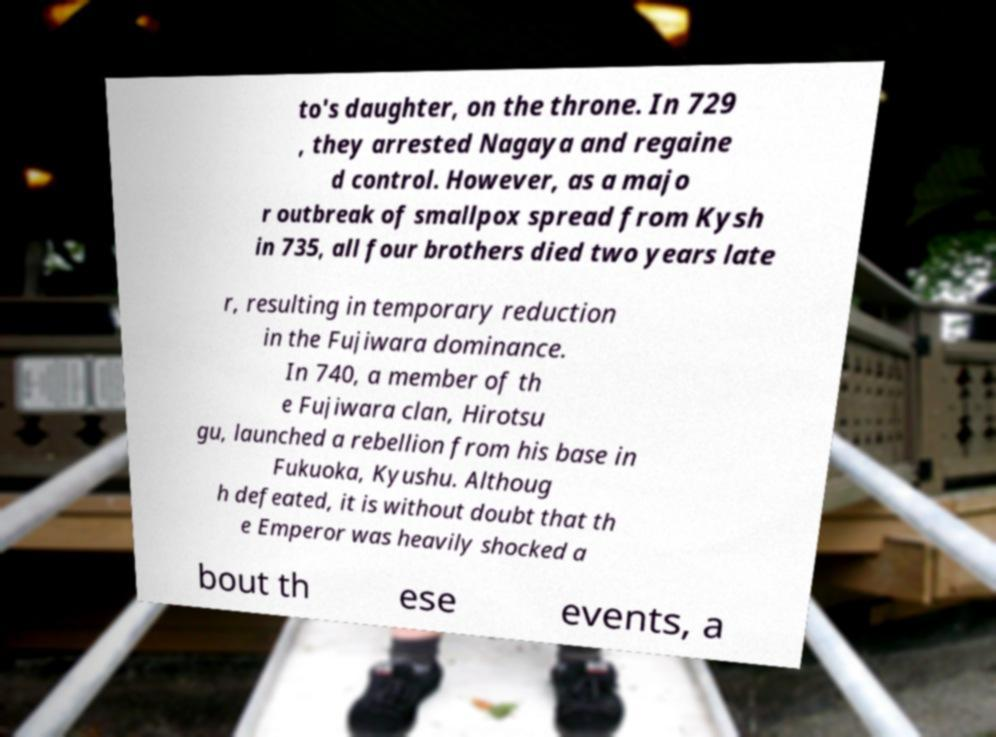Can you accurately transcribe the text from the provided image for me? to's daughter, on the throne. In 729 , they arrested Nagaya and regaine d control. However, as a majo r outbreak of smallpox spread from Kysh in 735, all four brothers died two years late r, resulting in temporary reduction in the Fujiwara dominance. In 740, a member of th e Fujiwara clan, Hirotsu gu, launched a rebellion from his base in Fukuoka, Kyushu. Althoug h defeated, it is without doubt that th e Emperor was heavily shocked a bout th ese events, a 